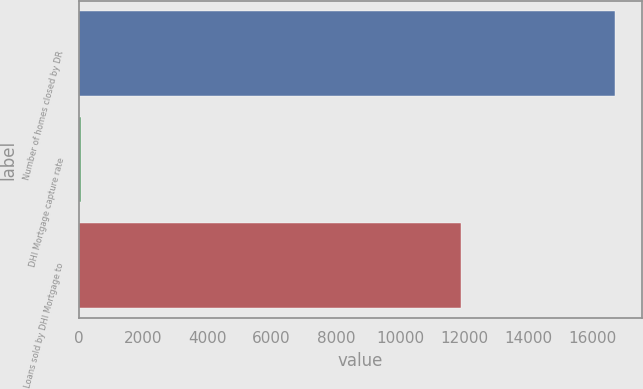Convert chart. <chart><loc_0><loc_0><loc_500><loc_500><bar_chart><fcel>Number of homes closed by DR<fcel>DHI Mortgage capture rate<fcel>Loans sold by DHI Mortgage to<nl><fcel>16695<fcel>61<fcel>11888<nl></chart> 